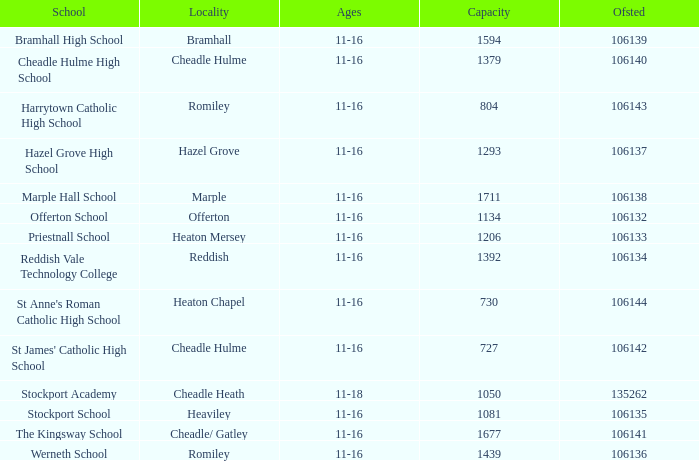What is the maximum occupancy of heaton chapel? 730.0. 